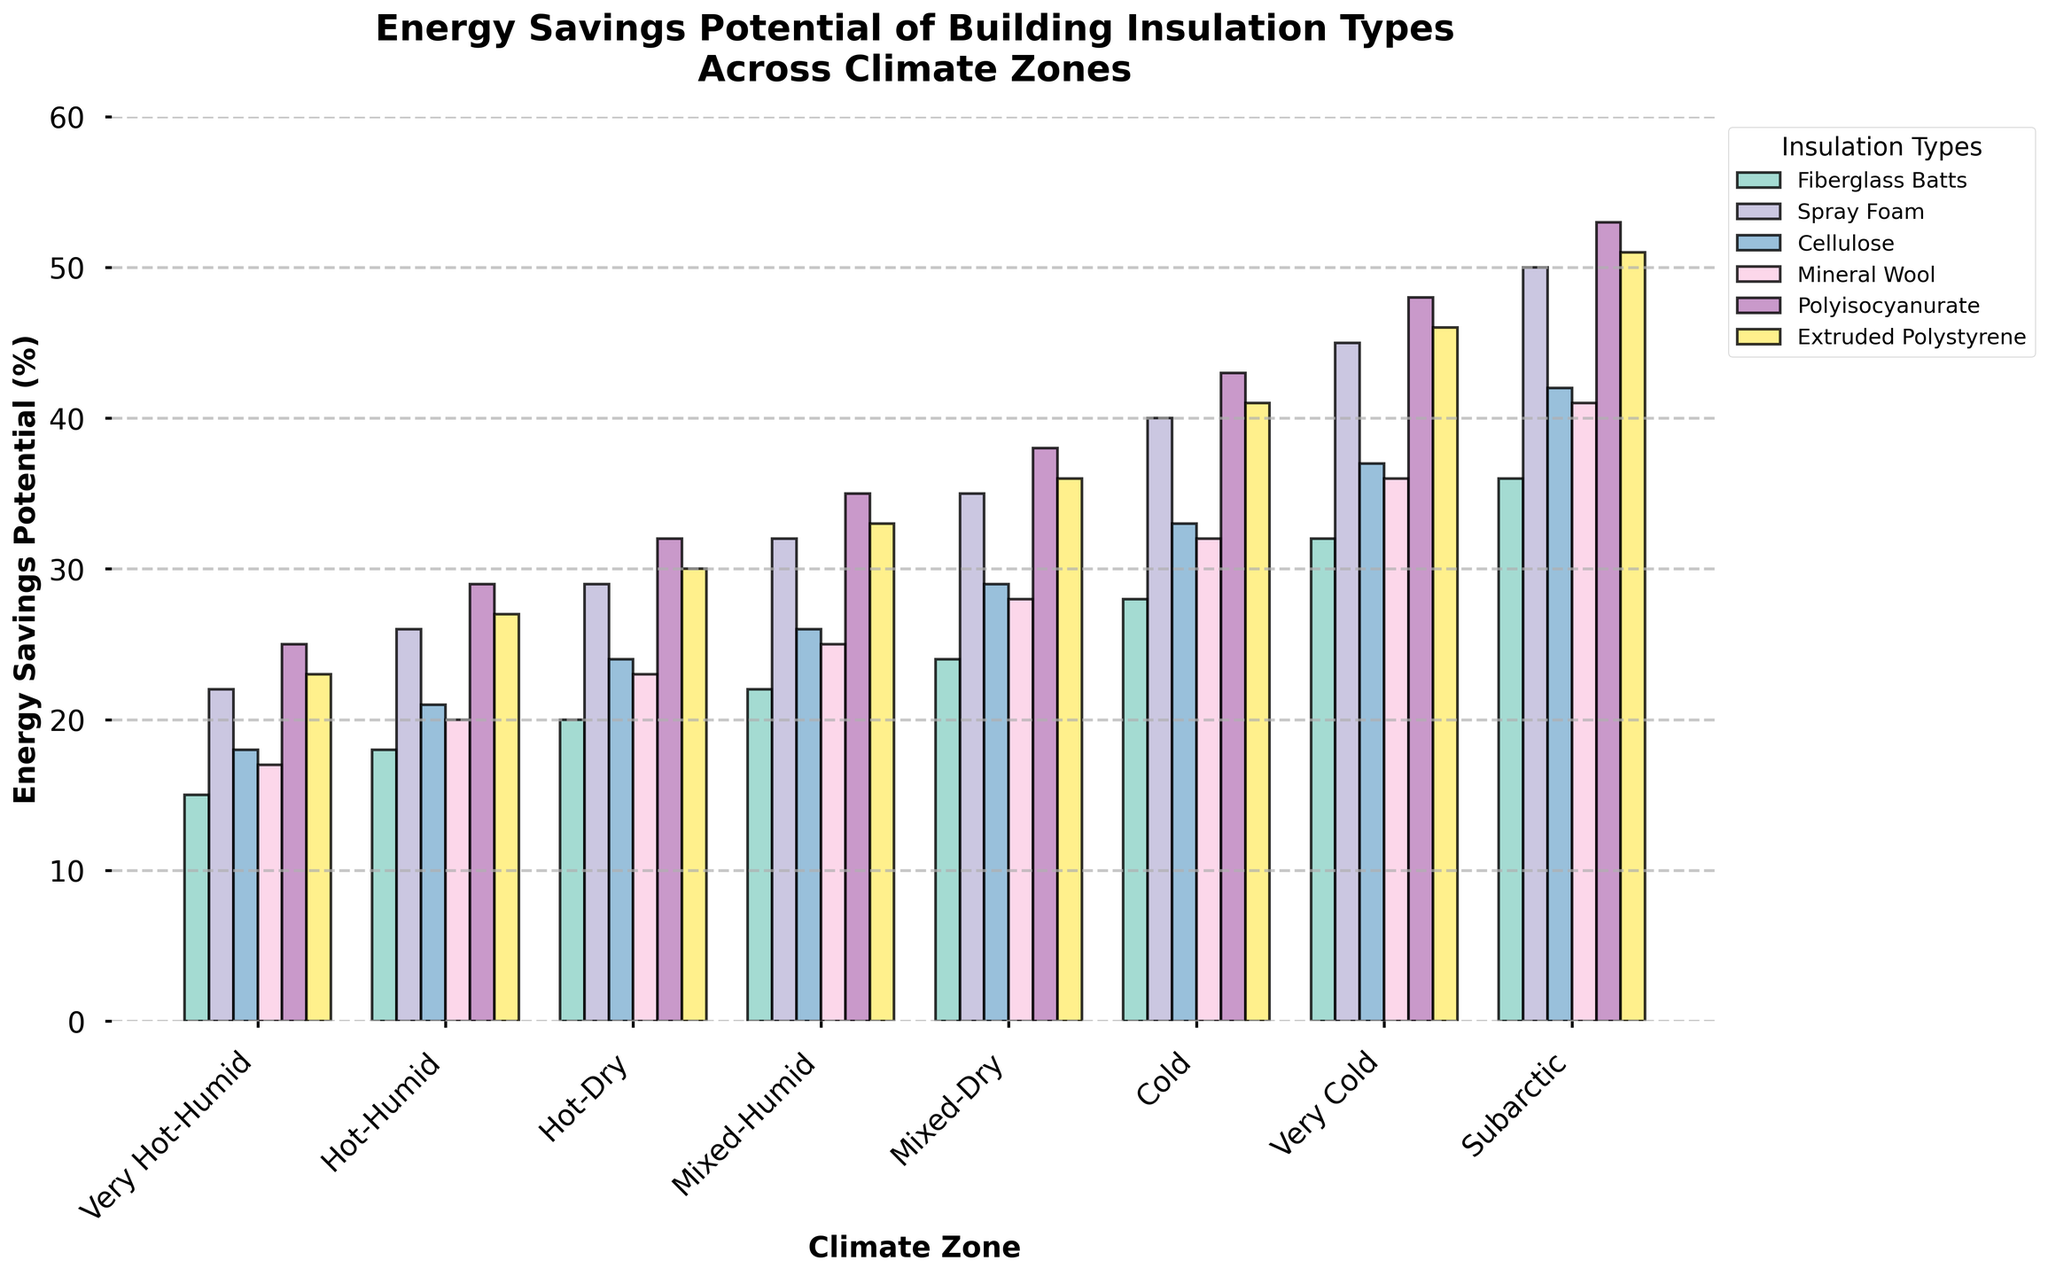Which insulation type offers the highest energy savings potential in the Very Cold climate zone? Look at the bars representing different insulation types in the Very Cold climate zone. Identify the highest bar, which corresponds to Polyisocyanurate.
Answer: Polyisocyanurate How does the energy savings potential of Fiberglass Batts in the Subarctic climate zone compare to Spray Foam in the same zone? Compare the heights of the bars for Fiberglass Batts and Spray Foam in the Subarctic climate zone. Fiberglass Batts has a height of 36, while Spray Foam has a height of 50.
Answer: Spray Foam is higher Which climate zone shows the greatest difference in energy savings potential between Cellulose and Mineral Wool? For each climate zone, subtract the energy savings potential of Mineral Wool from Cellulose. The greatest difference is in the Subarctic climate zone: 42 (Cellulose) - 41 (Mineral Wool) = 1.
Answer: Subarctic What is the average energy savings potential of Extruded Polystyrene across all climate zones? Add the values for Extruded Polystyrene across all climate zones (23+27+30+33+36+41+46+51) and divide by 8 (total number of climate zones). (23+27+30+33+36+41+46+51) / 8 = 35.87.
Answer: 35.87 Which insulation type sees the largest increase in energy savings potential from the Hot-Humid to the Cold climate zone? Calculate the difference in energy savings potential for each insulation type between the Hot-Humid and Cold climate zones. Identify the insulation type with the largest increase. Polyisocyanurate: 43-29 = 14.
Answer: Polyisocyanurate Which insulation type has the most consistent energy savings potential across all climate zones? Calculate the range (max value - min value) for each insulation type across all climate zones. The type with the smallest range is the most consistent. Fiberglass Batts ranges from 15 to 36 (21), while Spray Foam ranges from 22 to 50 (28), etc. Fiberglass Batts has the smallest range.
Answer: Fiberglass Batts In the Mixed-Dry climate zone, which two insulation types have the closest energy savings potential? Determine the difference in energy savings potential between each pair of insulation types in the Mixed-Dry climate zone. The closest values are those of Mineral Wool (28) and Cellulose (29), with a difference of 1.
Answer: Mineral Wool and Cellulose In which climate zone does Mineral Wool provide greater energy savings potential than Extruded Polystyrene? Compare the energy savings potentials of Mineral Wool and Extruded Polystyrene in each climate zone. Mineral Wool is never higher than Extruded Polystyrene in any climate zone.
Answer: None 